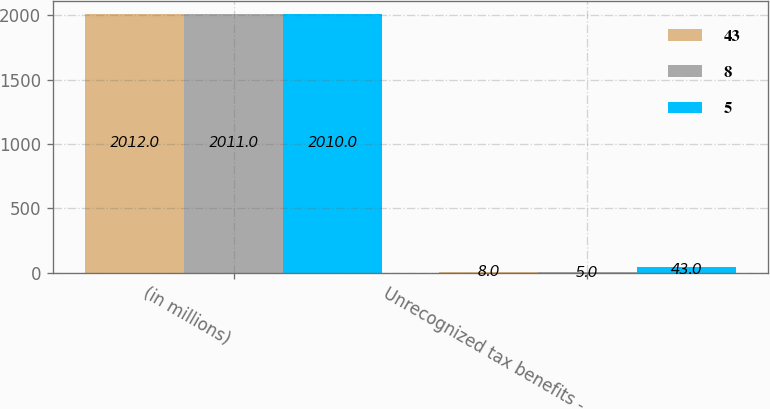Convert chart. <chart><loc_0><loc_0><loc_500><loc_500><stacked_bar_chart><ecel><fcel>(in millions)<fcel>Unrecognized tax benefits -<nl><fcel>43<fcel>2012<fcel>8<nl><fcel>8<fcel>2011<fcel>5<nl><fcel>5<fcel>2010<fcel>43<nl></chart> 